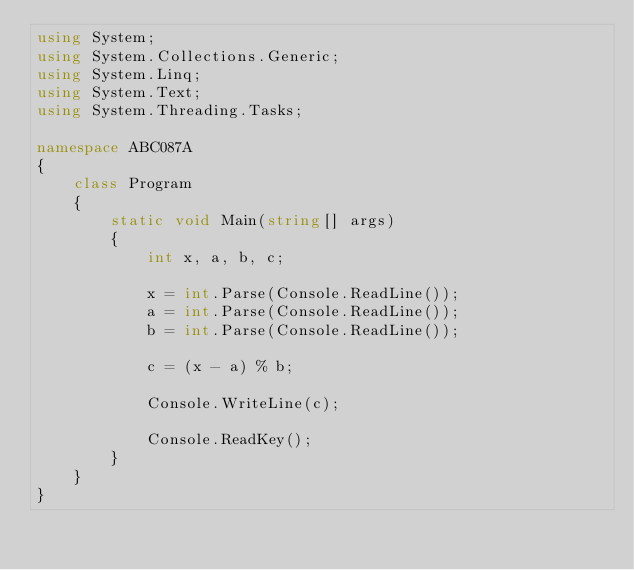<code> <loc_0><loc_0><loc_500><loc_500><_C#_>using System;
using System.Collections.Generic;
using System.Linq;
using System.Text;
using System.Threading.Tasks;

namespace ABC087A
{
    class Program
    {
        static void Main(string[] args)
        {
            int x, a, b, c;

            x = int.Parse(Console.ReadLine());
            a = int.Parse(Console.ReadLine());
            b = int.Parse(Console.ReadLine());

            c = (x - a) % b;

            Console.WriteLine(c);

            Console.ReadKey();
        }
    }
}</code> 